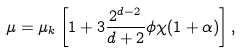Convert formula to latex. <formula><loc_0><loc_0><loc_500><loc_500>\mu = \mu _ { k } \left [ 1 + 3 \frac { 2 ^ { d - 2 } } { d + 2 } \phi \chi ( 1 + \alpha ) \right ] ,</formula> 